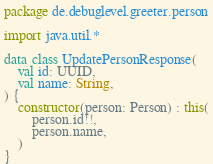Convert code to text. <code><loc_0><loc_0><loc_500><loc_500><_Kotlin_>package de.debuglevel.greeter.person

import java.util.*

data class UpdatePersonResponse(
    val id: UUID,
    val name: String,
) {
    constructor(person: Person) : this(
        person.id!!,
        person.name,
    )
}</code> 